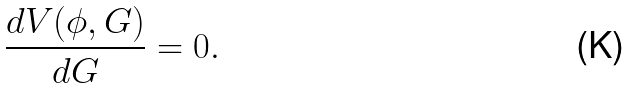Convert formula to latex. <formula><loc_0><loc_0><loc_500><loc_500>\frac { d V ( \phi , G ) } { d G } = 0 .</formula> 